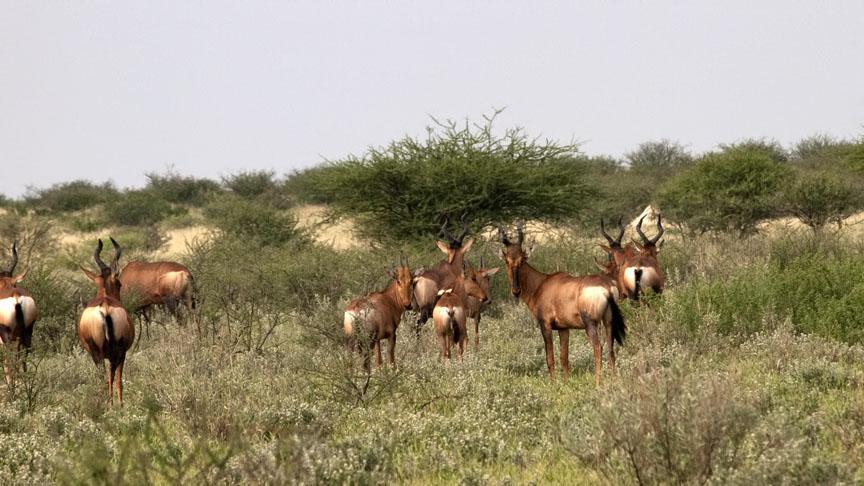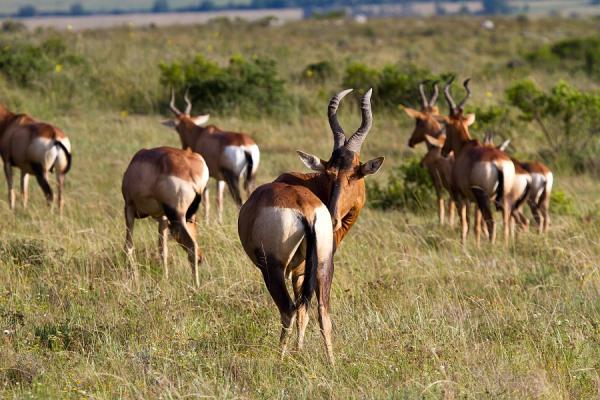The first image is the image on the left, the second image is the image on the right. Considering the images on both sides, is "The sky can not be seen in the image on the left." valid? Answer yes or no. No. 